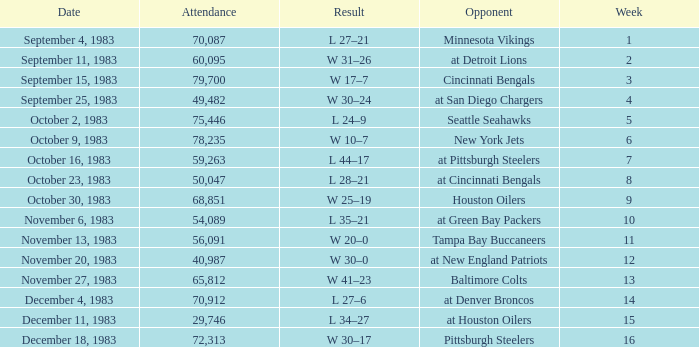What is the average attendance after week 16? None. 